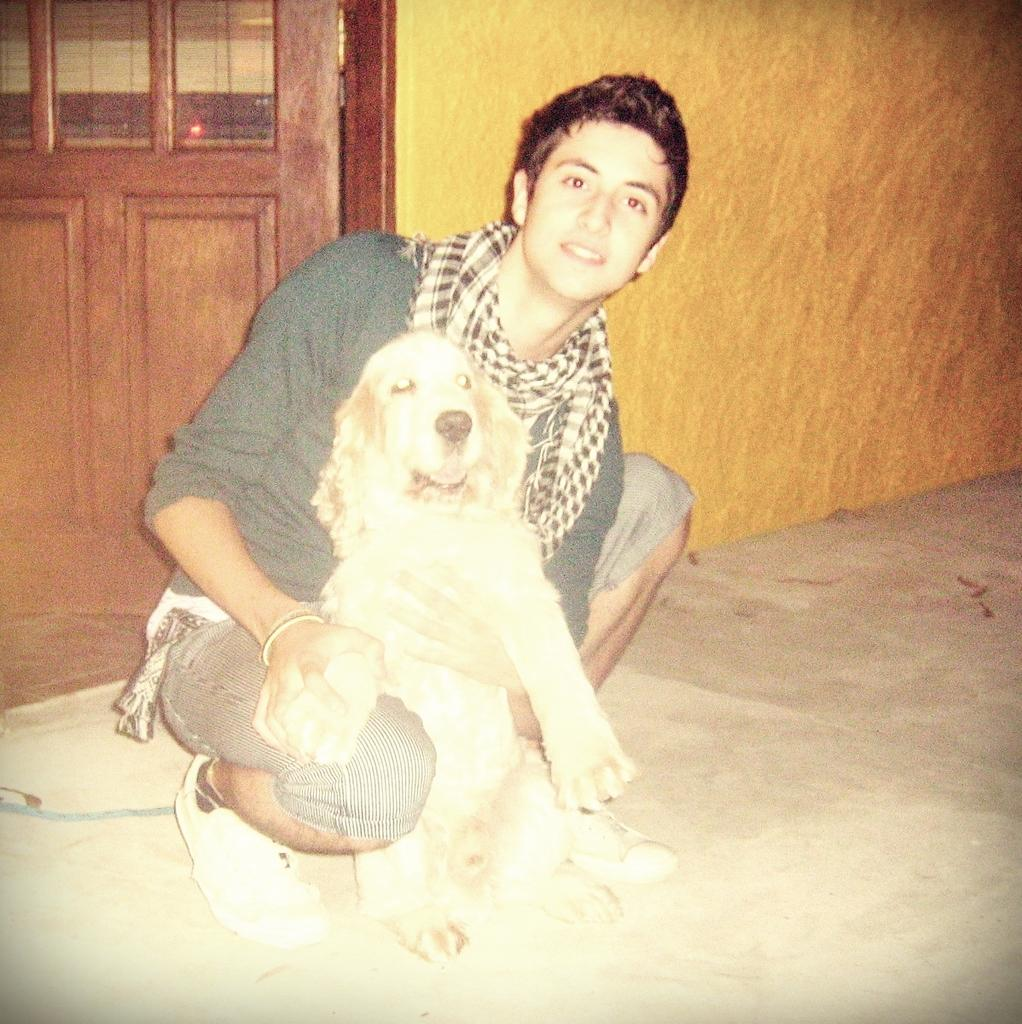Who or what is in the image? There is a person in the image. What is the person doing in the image? The person is holding a dog. Where are the person and the dog located in the image? The dog and person are on the floor. What can be seen in the background of the image? There is a door and a wall in the background of the image. What type of fairies can be seen flying around the person and the dog in the image? There are no fairies present in the image; it only features a person holding a dog on the floor. What base is supporting the person and the dog in the image? The person and the dog are on the floor, so there is no separate base supporting them. 